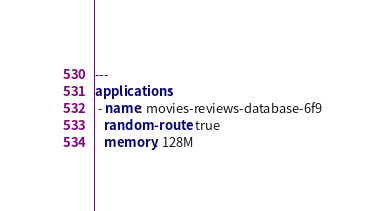Convert code to text. <code><loc_0><loc_0><loc_500><loc_500><_YAML_>---
applications:
 - name: movies-reviews-database-6f9
   random-route: true
   memory: 128M
</code> 